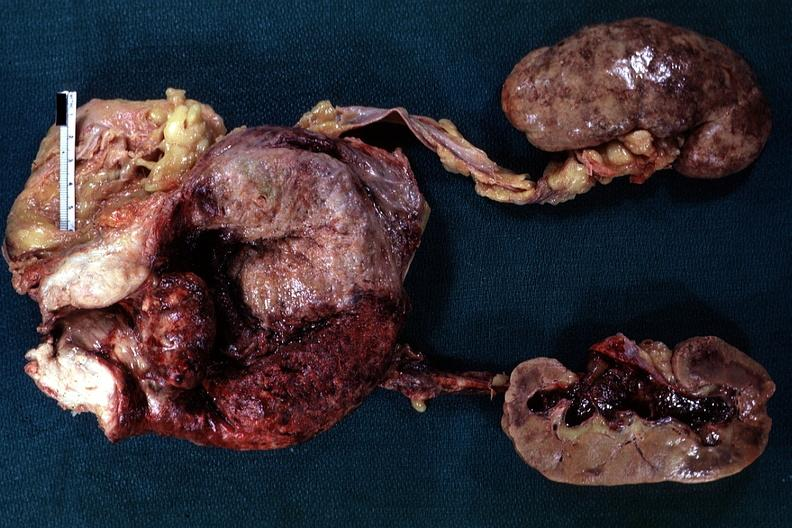how does this image show large median bar type lesion?
Answer the question using a single word or phrase. With severe cystitis 